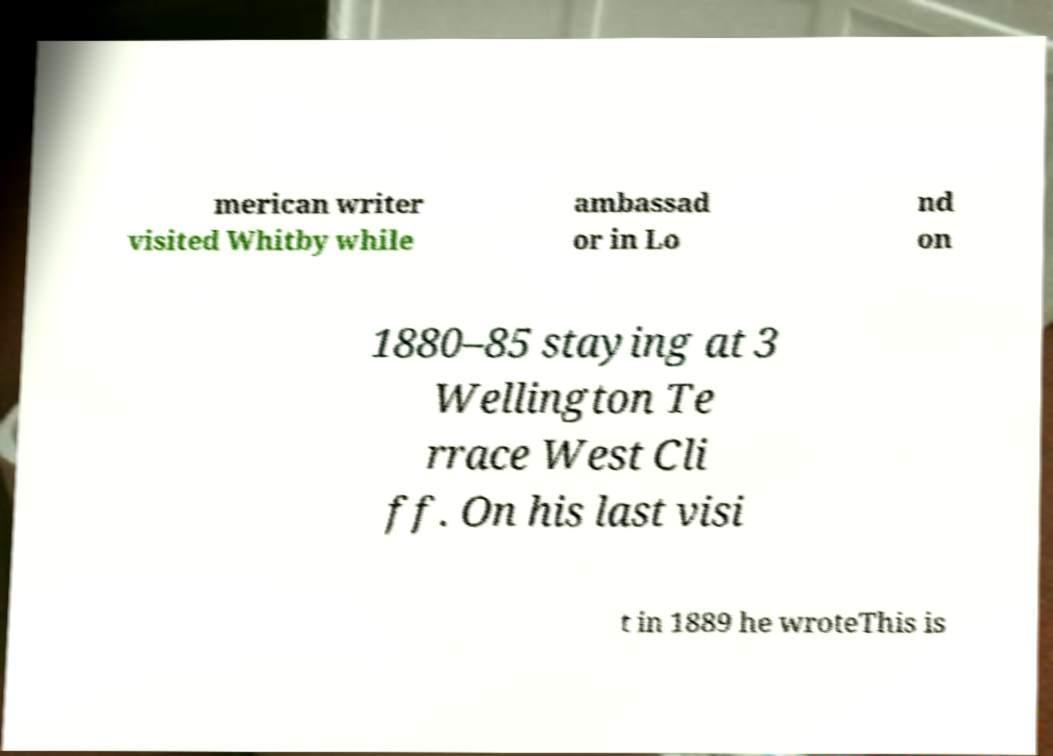Can you accurately transcribe the text from the provided image for me? merican writer visited Whitby while ambassad or in Lo nd on 1880–85 staying at 3 Wellington Te rrace West Cli ff. On his last visi t in 1889 he wroteThis is 